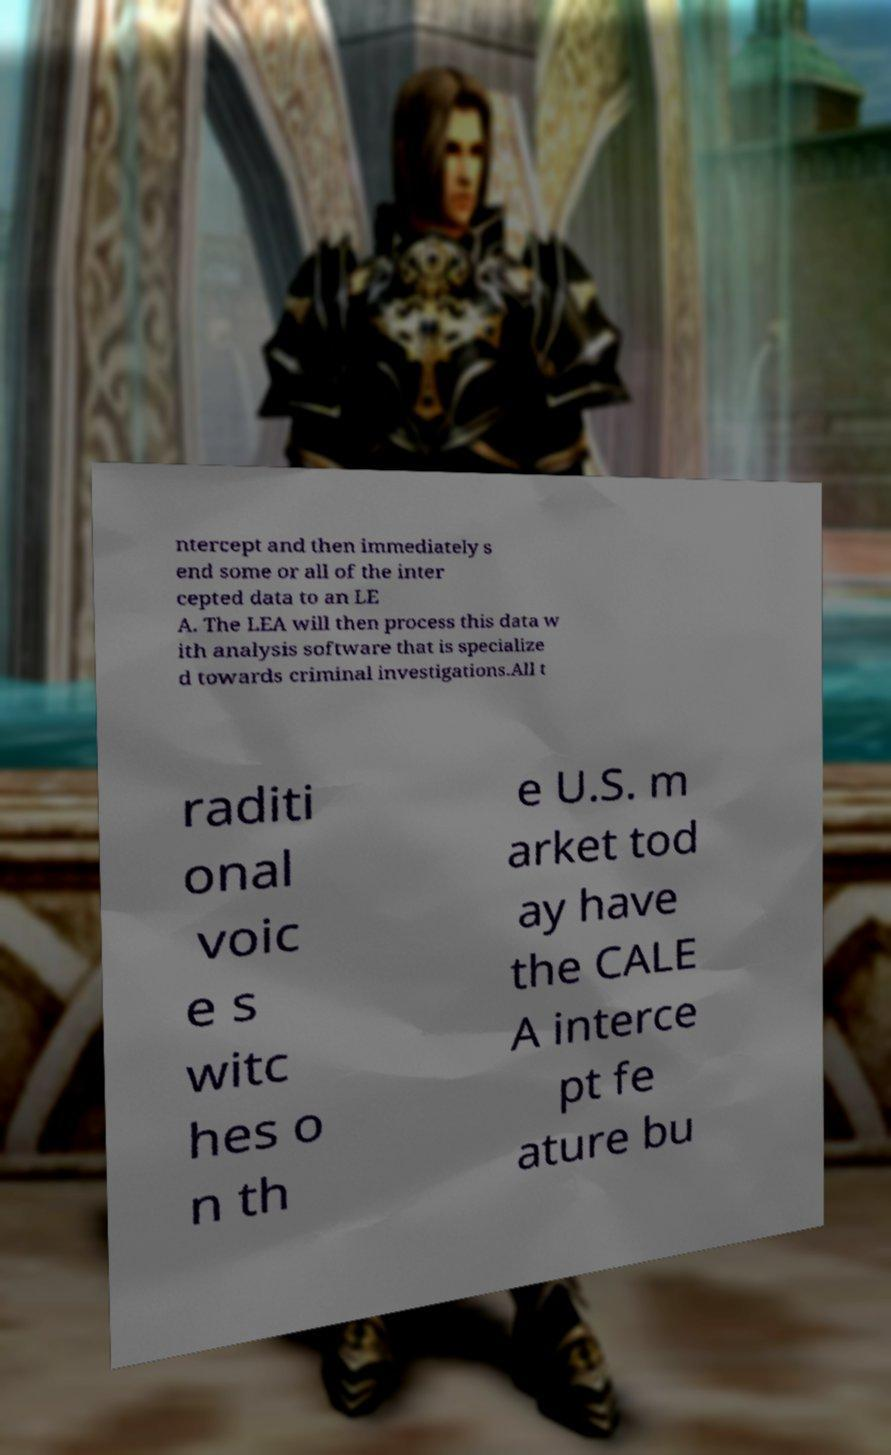I need the written content from this picture converted into text. Can you do that? ntercept and then immediately s end some or all of the inter cepted data to an LE A. The LEA will then process this data w ith analysis software that is specialize d towards criminal investigations.All t raditi onal voic e s witc hes o n th e U.S. m arket tod ay have the CALE A interce pt fe ature bu 